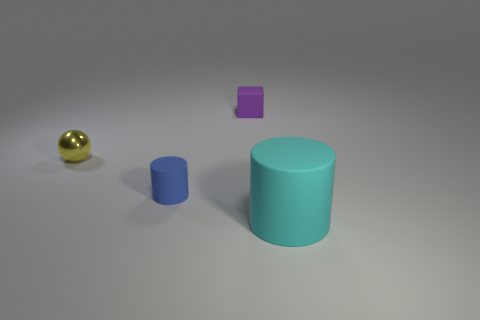Add 4 cyan rubber cylinders. How many objects exist? 8 Subtract all cubes. How many objects are left? 3 Subtract all large matte things. Subtract all purple things. How many objects are left? 2 Add 1 blue objects. How many blue objects are left? 2 Add 2 metal spheres. How many metal spheres exist? 3 Subtract 1 purple blocks. How many objects are left? 3 